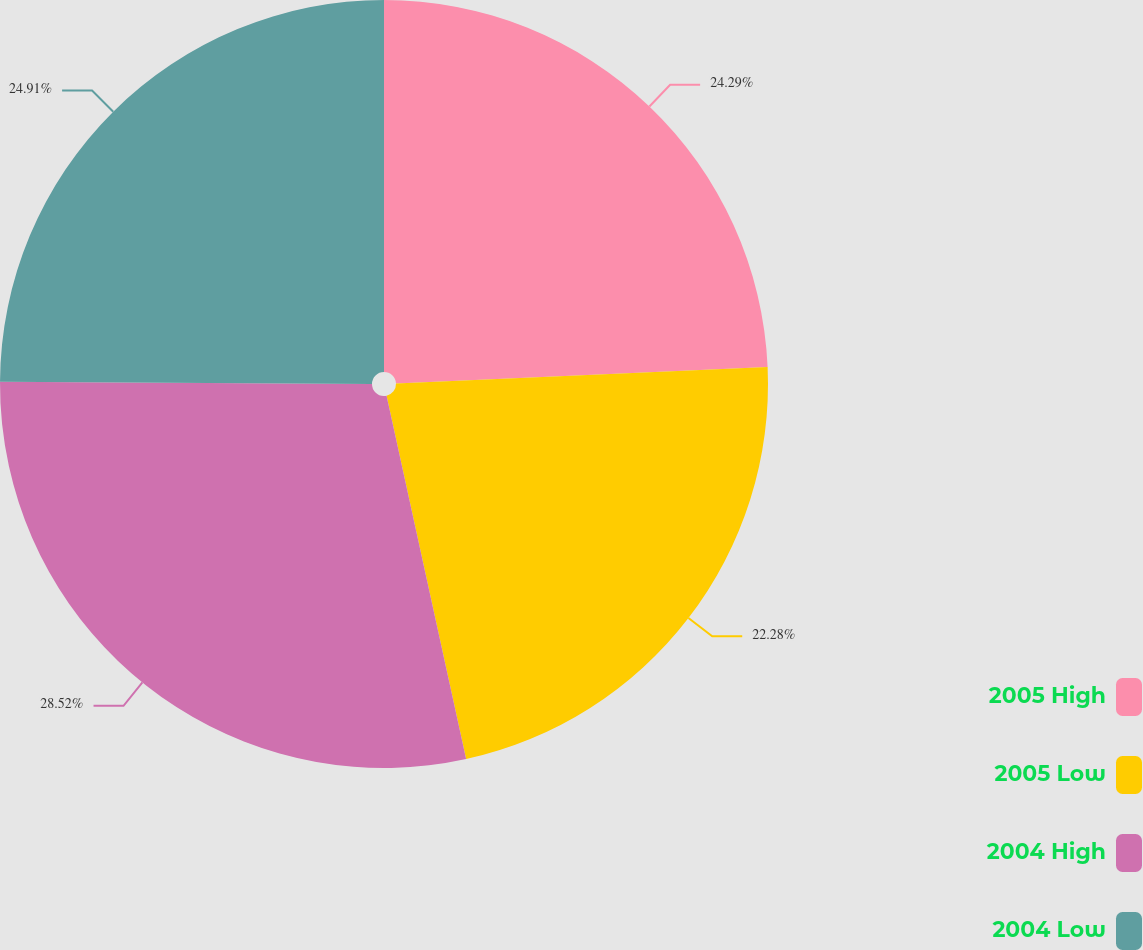Convert chart to OTSL. <chart><loc_0><loc_0><loc_500><loc_500><pie_chart><fcel>2005 High<fcel>2005 Low<fcel>2004 High<fcel>2004 Low<nl><fcel>24.29%<fcel>22.28%<fcel>28.52%<fcel>24.91%<nl></chart> 